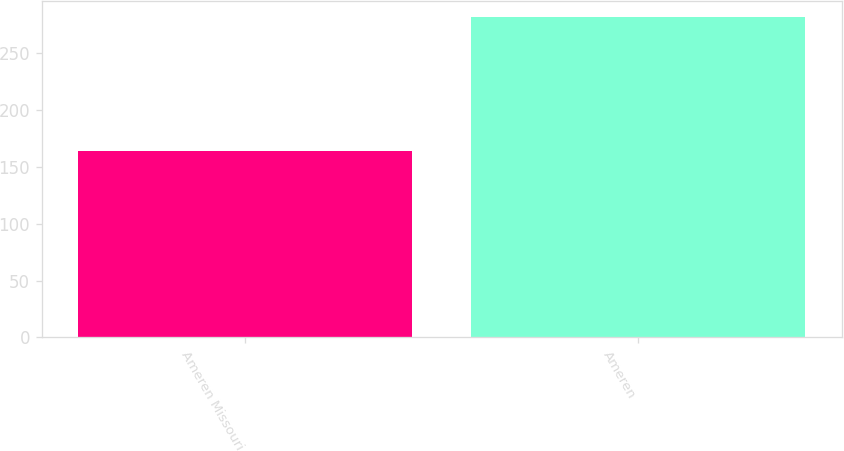<chart> <loc_0><loc_0><loc_500><loc_500><bar_chart><fcel>Ameren Missouri<fcel>Ameren<nl><fcel>164<fcel>282<nl></chart> 